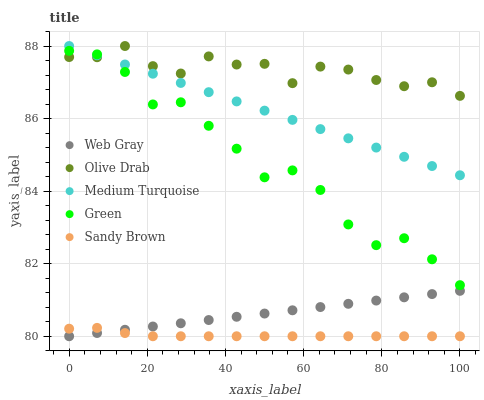Does Sandy Brown have the minimum area under the curve?
Answer yes or no. Yes. Does Olive Drab have the maximum area under the curve?
Answer yes or no. Yes. Does Web Gray have the minimum area under the curve?
Answer yes or no. No. Does Web Gray have the maximum area under the curve?
Answer yes or no. No. Is Web Gray the smoothest?
Answer yes or no. Yes. Is Green the roughest?
Answer yes or no. Yes. Is Green the smoothest?
Answer yes or no. No. Is Web Gray the roughest?
Answer yes or no. No. Does Sandy Brown have the lowest value?
Answer yes or no. Yes. Does Green have the lowest value?
Answer yes or no. No. Does Olive Drab have the highest value?
Answer yes or no. Yes. Does Web Gray have the highest value?
Answer yes or no. No. Is Sandy Brown less than Green?
Answer yes or no. Yes. Is Green greater than Sandy Brown?
Answer yes or no. Yes. Does Green intersect Medium Turquoise?
Answer yes or no. Yes. Is Green less than Medium Turquoise?
Answer yes or no. No. Is Green greater than Medium Turquoise?
Answer yes or no. No. Does Sandy Brown intersect Green?
Answer yes or no. No. 